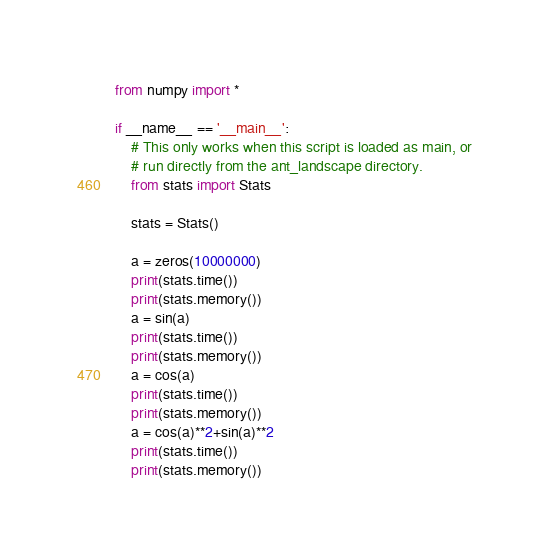<code> <loc_0><loc_0><loc_500><loc_500><_Python_>from numpy import *

if __name__ == '__main__':
    # This only works when this script is loaded as main, or
    # run directly from the ant_landscape directory.
    from stats import Stats

    stats = Stats()

    a = zeros(10000000)
    print(stats.time())
    print(stats.memory())
    a = sin(a)
    print(stats.time())
    print(stats.memory())
    a = cos(a)
    print(stats.time())
    print(stats.memory())
    a = cos(a)**2+sin(a)**2
    print(stats.time())
    print(stats.memory())
</code> 